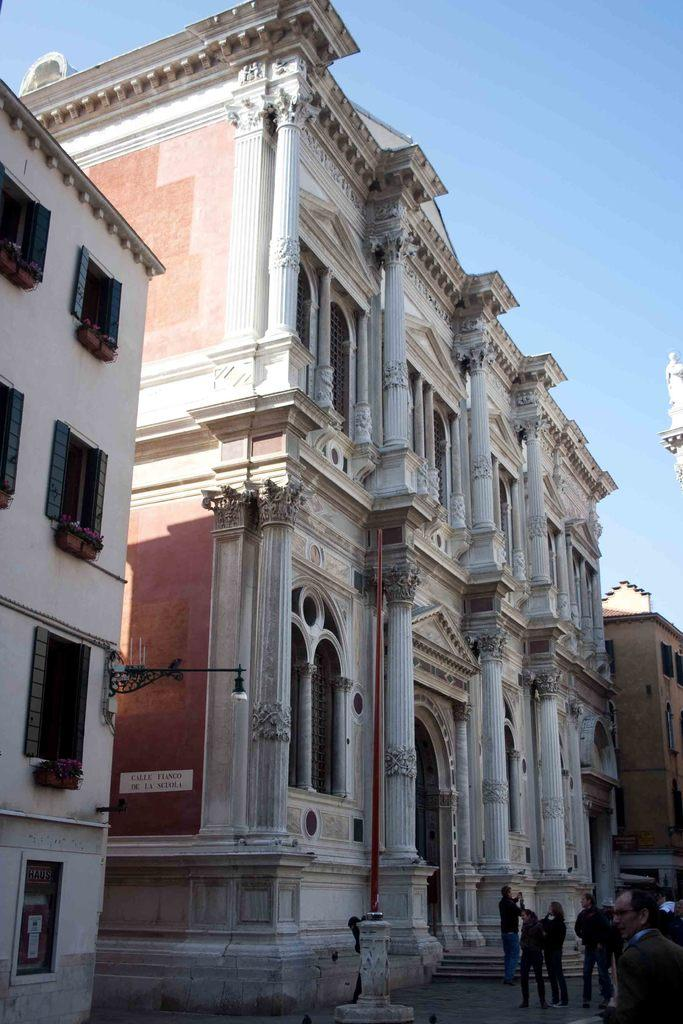What is happening in the image? There is a group of people standing in the image. What can be seen in the distance behind the people? There are buildings in the background of the image. What is the color of the sky in the image? The sky is blue and white in color. What type of example is the manager giving in the image? There is no manager or example present in the image; it only shows a group of people standing and buildings in the background. 